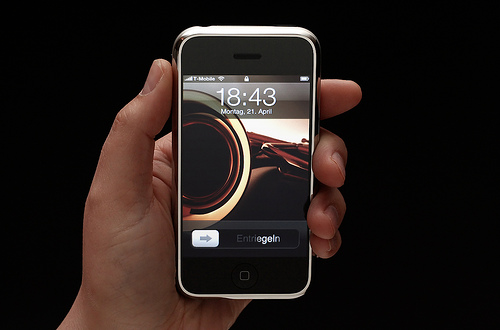<image>
Is there a human behind the phone? No. The human is not behind the phone. From this viewpoint, the human appears to be positioned elsewhere in the scene. 